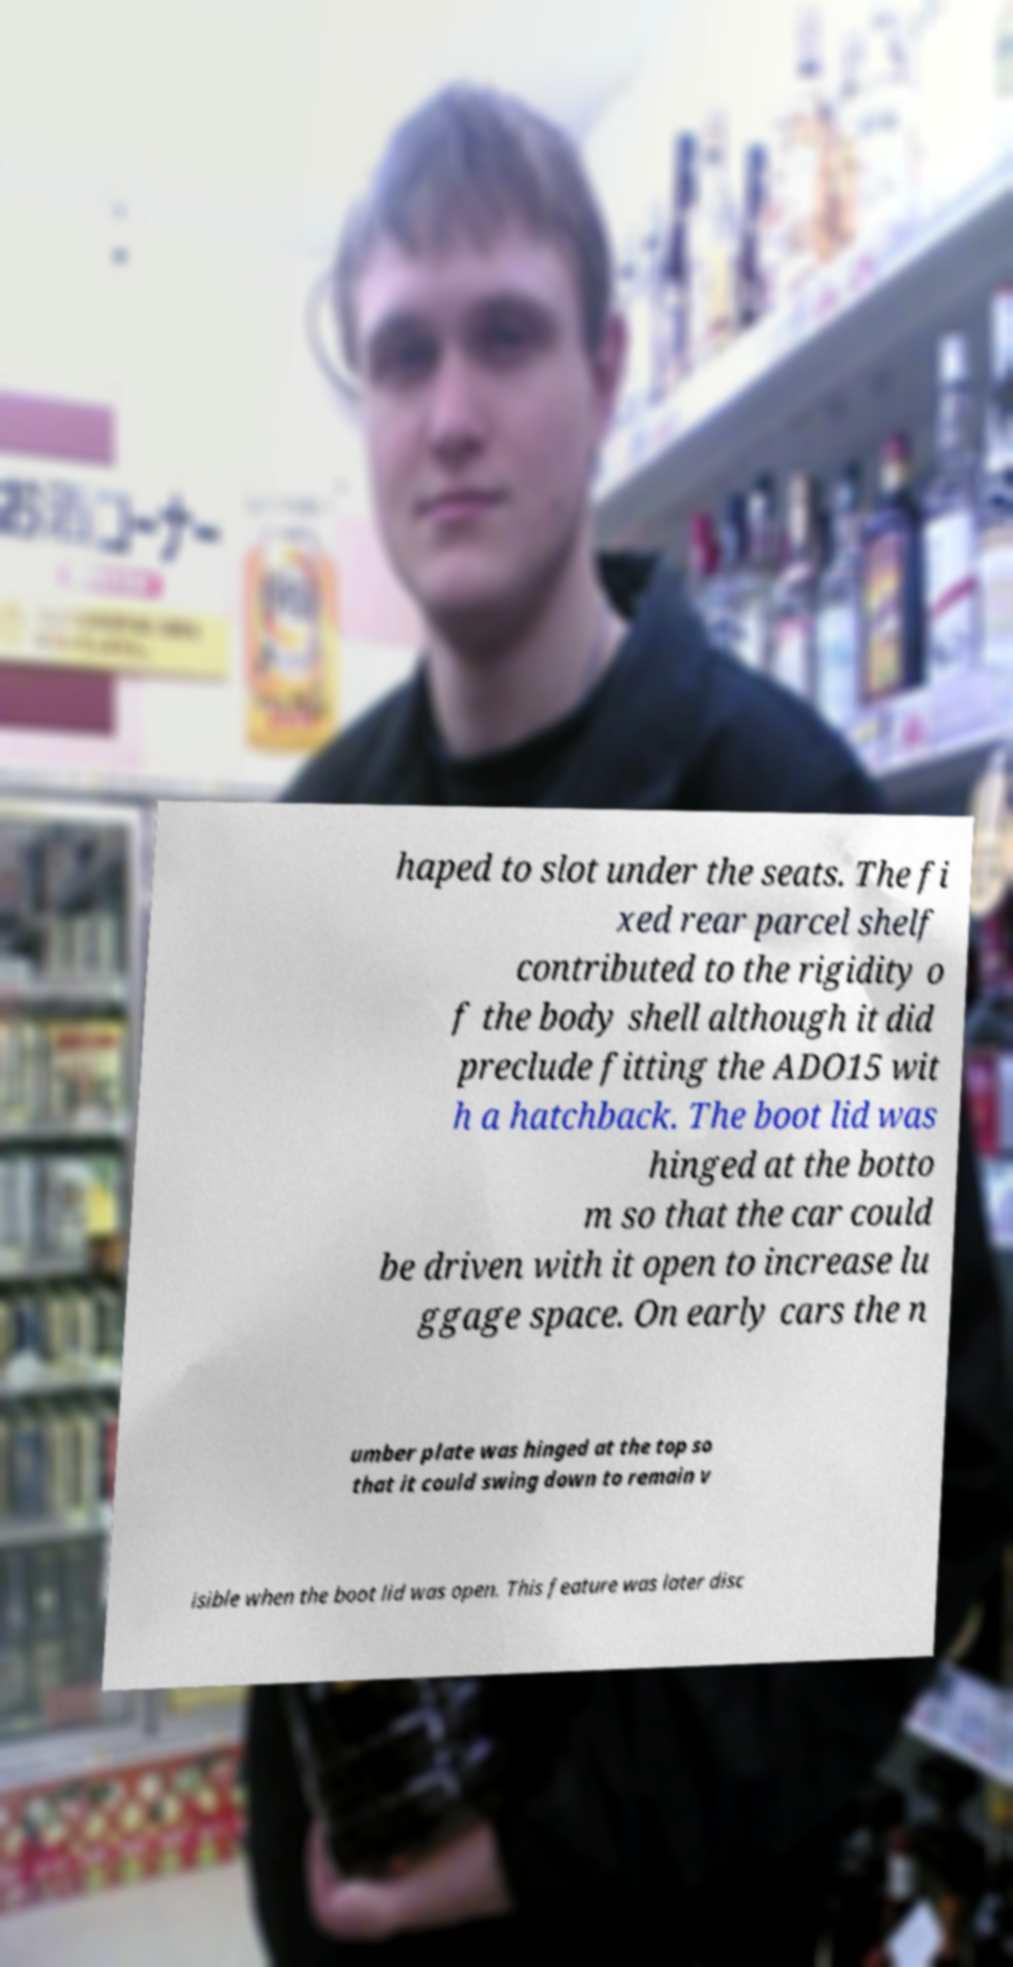Can you accurately transcribe the text from the provided image for me? haped to slot under the seats. The fi xed rear parcel shelf contributed to the rigidity o f the body shell although it did preclude fitting the ADO15 wit h a hatchback. The boot lid was hinged at the botto m so that the car could be driven with it open to increase lu ggage space. On early cars the n umber plate was hinged at the top so that it could swing down to remain v isible when the boot lid was open. This feature was later disc 